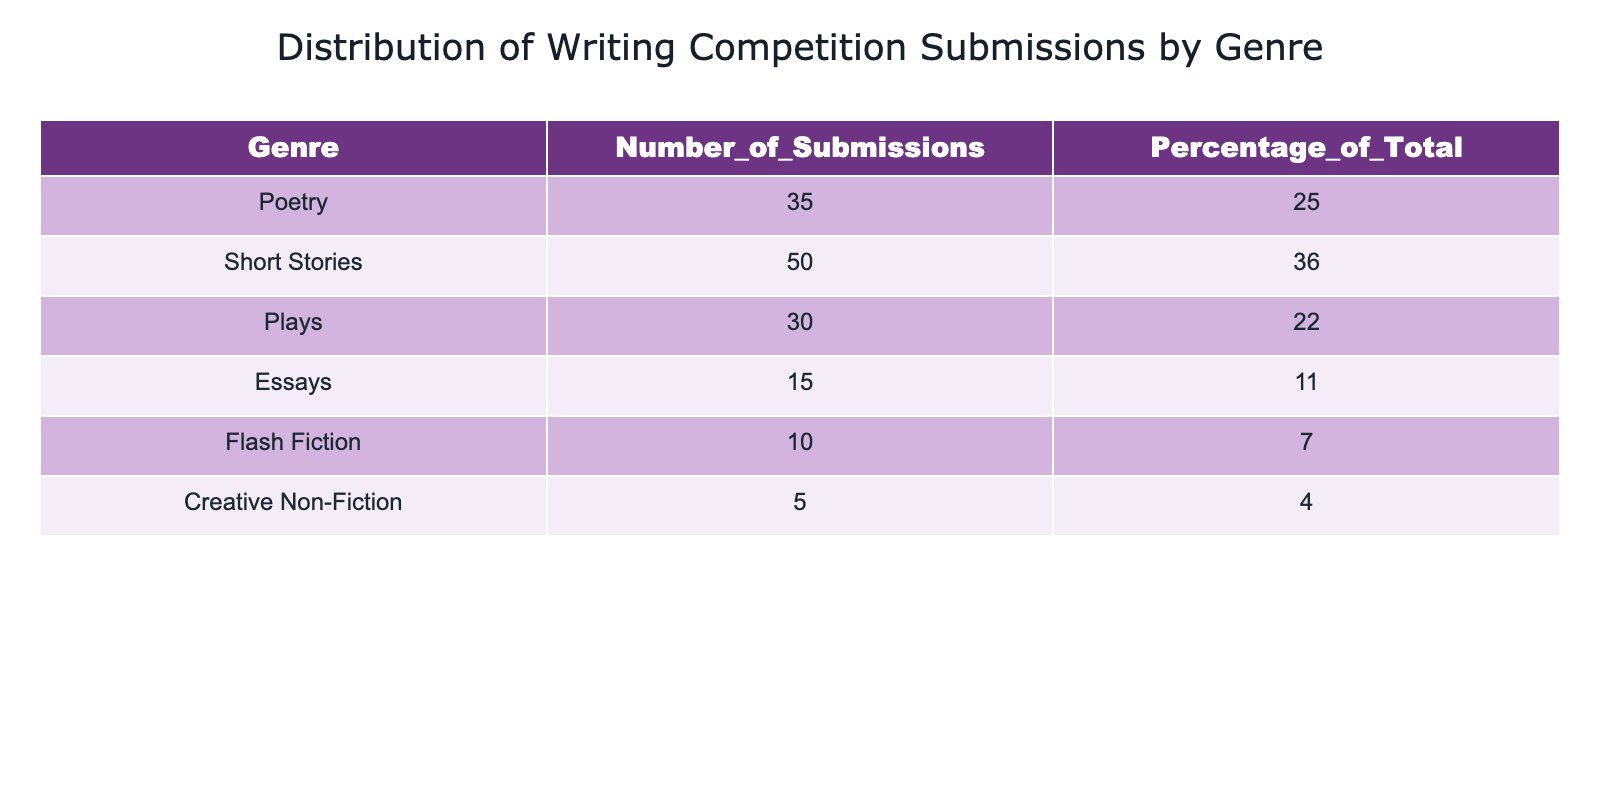What is the genre with the highest number of submissions? By inspecting the "Number_of_Submissions" column, the genre with the highest value is "Short Stories", which has 50 submissions.
Answer: Short Stories What is the percentage of submissions for Plays? Looking at the "Percentage_of_Total" column, the percentage for Plays is 22%.
Answer: 22% How many more submissions were received for Short Stories than for Poetry? The Number of Submissions for Short Stories is 50 and for Poetry is 35. Therefore, 50 - 35 = 15 more submissions for Short Stories.
Answer: 15 What is the total number of submissions across all genres? Summing up the Number of Submissions: 35 (Poetry) + 50 (Short Stories) + 30 (Plays) + 15 (Essays) + 10 (Flash Fiction) + 5 (Creative Non-Fiction) = 145 total submissions.
Answer: 145 Is the percentage of submissions for Essays greater than or equal to 10%? The percentage of submissions for Essays is 11%, which is greater than 10%.
Answer: Yes What is the average percentage of submissions for all genres? To find the average percentage, sum all percentages: 25 + 36 + 22 + 11 + 7 + 4 = 105, then divide by 6 genres: 105 / 6 = 17.5%.
Answer: 17.5% What genre has the least number of submissions, and how many submissions does it have? The genre with the least submissions is "Creative Non-Fiction," which has 5 submissions.
Answer: Creative Non-Fiction, 5 Which genres have more submissions than the average number of submissions? The average number of submissions is 145 / 6 = 24.17. Genres above this average are: Poetry (35), Short Stories (50), and Plays (30).
Answer: Poetry, Short Stories, Plays If you combine the submissions for Flash Fiction and Creative Non-Fiction, do they make up more than 10% of total submissions? Flash Fiction has 10 submissions and Creative Non-Fiction has 5 submissions, totaling 10 + 5 = 15 submissions. To find the percentage: (15 / 145) * 100 = 10.34%, which is greater than 10%.
Answer: Yes 